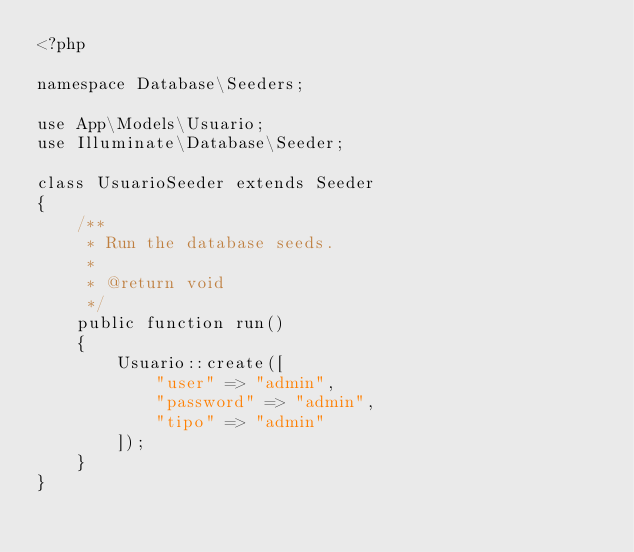Convert code to text. <code><loc_0><loc_0><loc_500><loc_500><_PHP_><?php

namespace Database\Seeders;

use App\Models\Usuario;
use Illuminate\Database\Seeder;

class UsuarioSeeder extends Seeder
{
    /**
     * Run the database seeds.
     *
     * @return void
     */
    public function run()
    {
        Usuario::create([
            "user" => "admin",
            "password" => "admin",
            "tipo" => "admin"
        ]);
    }
}
</code> 